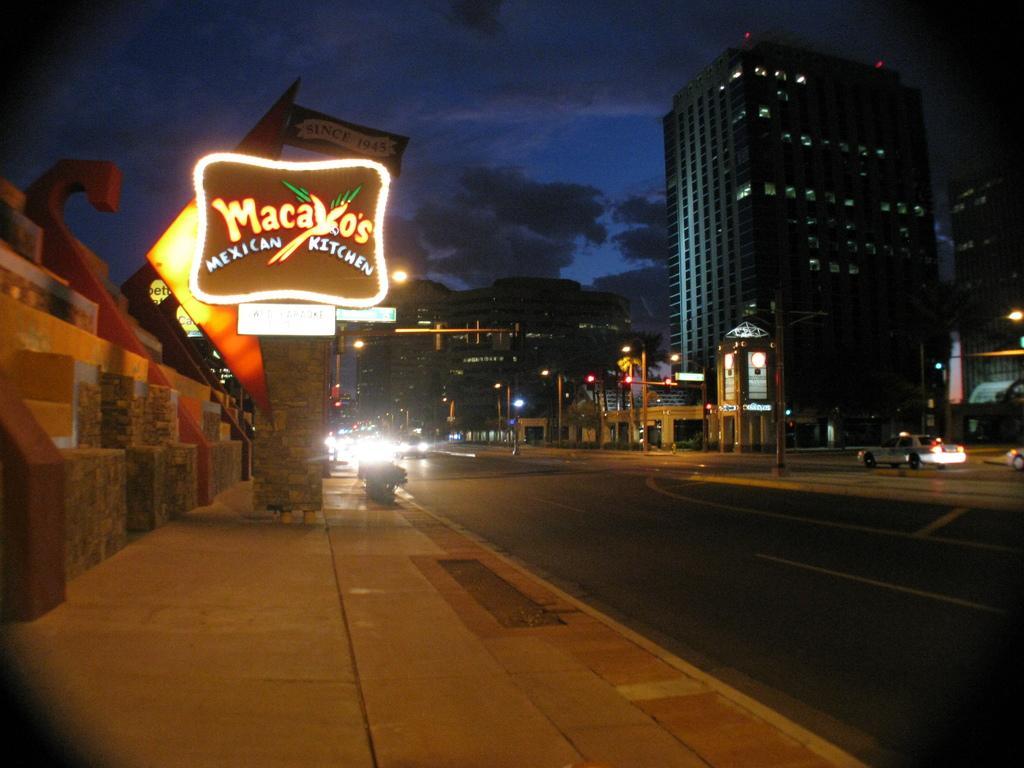How would you summarize this image in a sentence or two? In this image I can see the road, the sidewalk, few vehicles on the road, few boards, few lights, few poles and few buildings. In the background I can see the sky. 